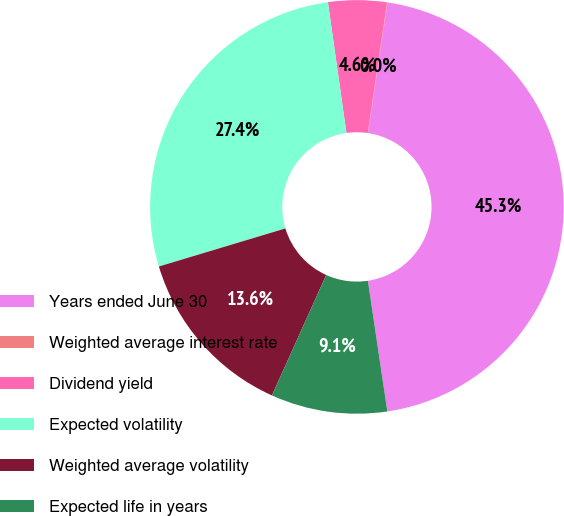Convert chart. <chart><loc_0><loc_0><loc_500><loc_500><pie_chart><fcel>Years ended June 30<fcel>Weighted average interest rate<fcel>Dividend yield<fcel>Expected volatility<fcel>Weighted average volatility<fcel>Expected life in years<nl><fcel>45.28%<fcel>0.04%<fcel>4.57%<fcel>27.41%<fcel>13.61%<fcel>9.09%<nl></chart> 